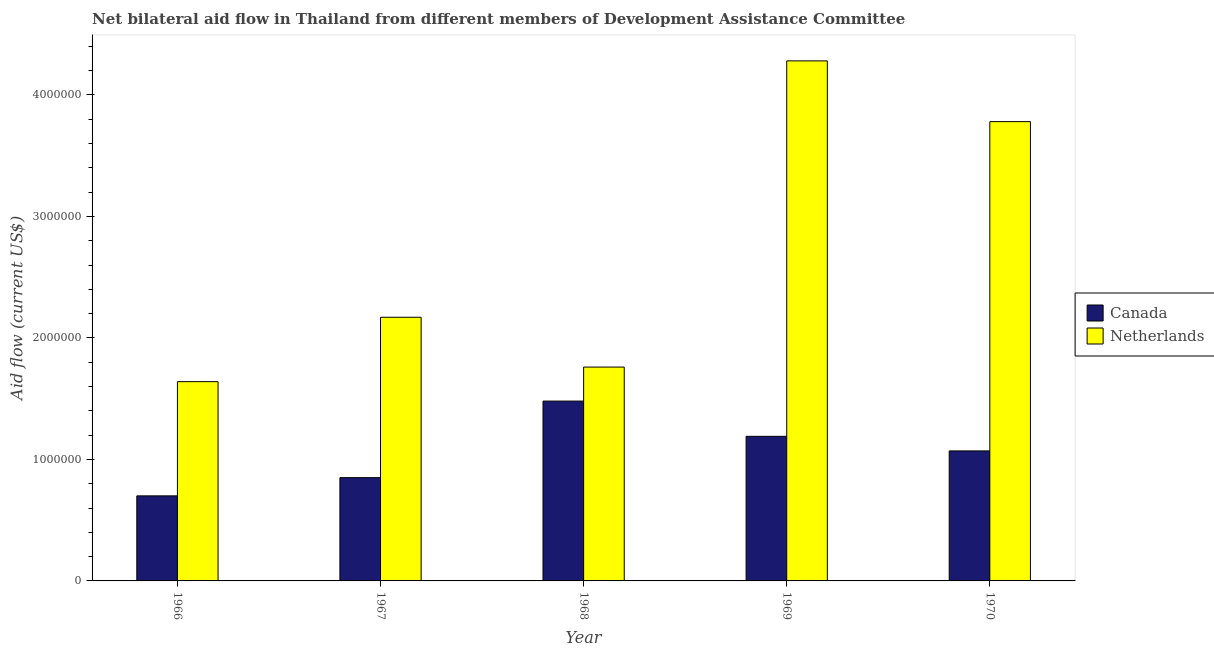How many different coloured bars are there?
Your answer should be compact. 2. How many groups of bars are there?
Give a very brief answer. 5. How many bars are there on the 5th tick from the right?
Give a very brief answer. 2. What is the label of the 3rd group of bars from the left?
Make the answer very short. 1968. In how many cases, is the number of bars for a given year not equal to the number of legend labels?
Make the answer very short. 0. What is the amount of aid given by canada in 1967?
Make the answer very short. 8.50e+05. Across all years, what is the maximum amount of aid given by netherlands?
Your answer should be very brief. 4.28e+06. Across all years, what is the minimum amount of aid given by netherlands?
Offer a very short reply. 1.64e+06. In which year was the amount of aid given by canada maximum?
Your answer should be compact. 1968. In which year was the amount of aid given by netherlands minimum?
Offer a terse response. 1966. What is the total amount of aid given by canada in the graph?
Give a very brief answer. 5.29e+06. What is the difference between the amount of aid given by netherlands in 1967 and that in 1968?
Your response must be concise. 4.10e+05. What is the difference between the amount of aid given by canada in 1969 and the amount of aid given by netherlands in 1970?
Give a very brief answer. 1.20e+05. What is the average amount of aid given by canada per year?
Your answer should be very brief. 1.06e+06. In the year 1966, what is the difference between the amount of aid given by netherlands and amount of aid given by canada?
Offer a terse response. 0. What is the ratio of the amount of aid given by netherlands in 1967 to that in 1968?
Give a very brief answer. 1.23. Is the amount of aid given by netherlands in 1967 less than that in 1970?
Provide a succinct answer. Yes. Is the difference between the amount of aid given by netherlands in 1967 and 1970 greater than the difference between the amount of aid given by canada in 1967 and 1970?
Offer a very short reply. No. What is the difference between the highest and the second highest amount of aid given by netherlands?
Your response must be concise. 5.00e+05. What is the difference between the highest and the lowest amount of aid given by canada?
Your answer should be compact. 7.80e+05. Is the sum of the amount of aid given by canada in 1966 and 1970 greater than the maximum amount of aid given by netherlands across all years?
Keep it short and to the point. Yes. What does the 1st bar from the right in 1970 represents?
Offer a very short reply. Netherlands. How many bars are there?
Keep it short and to the point. 10. Are the values on the major ticks of Y-axis written in scientific E-notation?
Your answer should be very brief. No. How are the legend labels stacked?
Provide a short and direct response. Vertical. What is the title of the graph?
Your response must be concise. Net bilateral aid flow in Thailand from different members of Development Assistance Committee. What is the Aid flow (current US$) in Netherlands in 1966?
Offer a terse response. 1.64e+06. What is the Aid flow (current US$) of Canada in 1967?
Provide a short and direct response. 8.50e+05. What is the Aid flow (current US$) of Netherlands in 1967?
Provide a short and direct response. 2.17e+06. What is the Aid flow (current US$) in Canada in 1968?
Offer a terse response. 1.48e+06. What is the Aid flow (current US$) of Netherlands in 1968?
Offer a very short reply. 1.76e+06. What is the Aid flow (current US$) of Canada in 1969?
Make the answer very short. 1.19e+06. What is the Aid flow (current US$) of Netherlands in 1969?
Your answer should be compact. 4.28e+06. What is the Aid flow (current US$) in Canada in 1970?
Keep it short and to the point. 1.07e+06. What is the Aid flow (current US$) in Netherlands in 1970?
Make the answer very short. 3.78e+06. Across all years, what is the maximum Aid flow (current US$) of Canada?
Your answer should be compact. 1.48e+06. Across all years, what is the maximum Aid flow (current US$) in Netherlands?
Give a very brief answer. 4.28e+06. Across all years, what is the minimum Aid flow (current US$) of Netherlands?
Provide a short and direct response. 1.64e+06. What is the total Aid flow (current US$) in Canada in the graph?
Ensure brevity in your answer.  5.29e+06. What is the total Aid flow (current US$) of Netherlands in the graph?
Provide a short and direct response. 1.36e+07. What is the difference between the Aid flow (current US$) of Canada in 1966 and that in 1967?
Give a very brief answer. -1.50e+05. What is the difference between the Aid flow (current US$) in Netherlands in 1966 and that in 1967?
Offer a terse response. -5.30e+05. What is the difference between the Aid flow (current US$) of Canada in 1966 and that in 1968?
Offer a very short reply. -7.80e+05. What is the difference between the Aid flow (current US$) of Netherlands in 1966 and that in 1968?
Offer a terse response. -1.20e+05. What is the difference between the Aid flow (current US$) of Canada in 1966 and that in 1969?
Give a very brief answer. -4.90e+05. What is the difference between the Aid flow (current US$) of Netherlands in 1966 and that in 1969?
Give a very brief answer. -2.64e+06. What is the difference between the Aid flow (current US$) in Canada in 1966 and that in 1970?
Offer a very short reply. -3.70e+05. What is the difference between the Aid flow (current US$) of Netherlands in 1966 and that in 1970?
Provide a short and direct response. -2.14e+06. What is the difference between the Aid flow (current US$) of Canada in 1967 and that in 1968?
Provide a succinct answer. -6.30e+05. What is the difference between the Aid flow (current US$) in Netherlands in 1967 and that in 1968?
Provide a succinct answer. 4.10e+05. What is the difference between the Aid flow (current US$) of Netherlands in 1967 and that in 1969?
Provide a short and direct response. -2.11e+06. What is the difference between the Aid flow (current US$) of Canada in 1967 and that in 1970?
Give a very brief answer. -2.20e+05. What is the difference between the Aid flow (current US$) of Netherlands in 1967 and that in 1970?
Give a very brief answer. -1.61e+06. What is the difference between the Aid flow (current US$) in Netherlands in 1968 and that in 1969?
Provide a short and direct response. -2.52e+06. What is the difference between the Aid flow (current US$) in Netherlands in 1968 and that in 1970?
Offer a terse response. -2.02e+06. What is the difference between the Aid flow (current US$) of Canada in 1969 and that in 1970?
Keep it short and to the point. 1.20e+05. What is the difference between the Aid flow (current US$) in Canada in 1966 and the Aid flow (current US$) in Netherlands in 1967?
Give a very brief answer. -1.47e+06. What is the difference between the Aid flow (current US$) in Canada in 1966 and the Aid flow (current US$) in Netherlands in 1968?
Your answer should be compact. -1.06e+06. What is the difference between the Aid flow (current US$) of Canada in 1966 and the Aid flow (current US$) of Netherlands in 1969?
Give a very brief answer. -3.58e+06. What is the difference between the Aid flow (current US$) of Canada in 1966 and the Aid flow (current US$) of Netherlands in 1970?
Keep it short and to the point. -3.08e+06. What is the difference between the Aid flow (current US$) of Canada in 1967 and the Aid flow (current US$) of Netherlands in 1968?
Your answer should be compact. -9.10e+05. What is the difference between the Aid flow (current US$) of Canada in 1967 and the Aid flow (current US$) of Netherlands in 1969?
Provide a succinct answer. -3.43e+06. What is the difference between the Aid flow (current US$) in Canada in 1967 and the Aid flow (current US$) in Netherlands in 1970?
Ensure brevity in your answer.  -2.93e+06. What is the difference between the Aid flow (current US$) of Canada in 1968 and the Aid flow (current US$) of Netherlands in 1969?
Your answer should be very brief. -2.80e+06. What is the difference between the Aid flow (current US$) of Canada in 1968 and the Aid flow (current US$) of Netherlands in 1970?
Provide a succinct answer. -2.30e+06. What is the difference between the Aid flow (current US$) of Canada in 1969 and the Aid flow (current US$) of Netherlands in 1970?
Your response must be concise. -2.59e+06. What is the average Aid flow (current US$) of Canada per year?
Make the answer very short. 1.06e+06. What is the average Aid flow (current US$) of Netherlands per year?
Provide a short and direct response. 2.73e+06. In the year 1966, what is the difference between the Aid flow (current US$) of Canada and Aid flow (current US$) of Netherlands?
Your answer should be compact. -9.40e+05. In the year 1967, what is the difference between the Aid flow (current US$) in Canada and Aid flow (current US$) in Netherlands?
Your answer should be very brief. -1.32e+06. In the year 1968, what is the difference between the Aid flow (current US$) of Canada and Aid flow (current US$) of Netherlands?
Keep it short and to the point. -2.80e+05. In the year 1969, what is the difference between the Aid flow (current US$) of Canada and Aid flow (current US$) of Netherlands?
Make the answer very short. -3.09e+06. In the year 1970, what is the difference between the Aid flow (current US$) in Canada and Aid flow (current US$) in Netherlands?
Ensure brevity in your answer.  -2.71e+06. What is the ratio of the Aid flow (current US$) of Canada in 1966 to that in 1967?
Make the answer very short. 0.82. What is the ratio of the Aid flow (current US$) in Netherlands in 1966 to that in 1967?
Make the answer very short. 0.76. What is the ratio of the Aid flow (current US$) in Canada in 1966 to that in 1968?
Ensure brevity in your answer.  0.47. What is the ratio of the Aid flow (current US$) in Netherlands in 1966 to that in 1968?
Ensure brevity in your answer.  0.93. What is the ratio of the Aid flow (current US$) of Canada in 1966 to that in 1969?
Your answer should be compact. 0.59. What is the ratio of the Aid flow (current US$) of Netherlands in 1966 to that in 1969?
Offer a terse response. 0.38. What is the ratio of the Aid flow (current US$) of Canada in 1966 to that in 1970?
Provide a succinct answer. 0.65. What is the ratio of the Aid flow (current US$) in Netherlands in 1966 to that in 1970?
Provide a succinct answer. 0.43. What is the ratio of the Aid flow (current US$) in Canada in 1967 to that in 1968?
Make the answer very short. 0.57. What is the ratio of the Aid flow (current US$) of Netherlands in 1967 to that in 1968?
Provide a succinct answer. 1.23. What is the ratio of the Aid flow (current US$) of Netherlands in 1967 to that in 1969?
Ensure brevity in your answer.  0.51. What is the ratio of the Aid flow (current US$) in Canada in 1967 to that in 1970?
Give a very brief answer. 0.79. What is the ratio of the Aid flow (current US$) in Netherlands in 1967 to that in 1970?
Provide a short and direct response. 0.57. What is the ratio of the Aid flow (current US$) of Canada in 1968 to that in 1969?
Give a very brief answer. 1.24. What is the ratio of the Aid flow (current US$) in Netherlands in 1968 to that in 1969?
Your response must be concise. 0.41. What is the ratio of the Aid flow (current US$) of Canada in 1968 to that in 1970?
Your answer should be compact. 1.38. What is the ratio of the Aid flow (current US$) of Netherlands in 1968 to that in 1970?
Give a very brief answer. 0.47. What is the ratio of the Aid flow (current US$) in Canada in 1969 to that in 1970?
Ensure brevity in your answer.  1.11. What is the ratio of the Aid flow (current US$) in Netherlands in 1969 to that in 1970?
Make the answer very short. 1.13. What is the difference between the highest and the second highest Aid flow (current US$) in Canada?
Make the answer very short. 2.90e+05. What is the difference between the highest and the lowest Aid flow (current US$) in Canada?
Ensure brevity in your answer.  7.80e+05. What is the difference between the highest and the lowest Aid flow (current US$) of Netherlands?
Your response must be concise. 2.64e+06. 